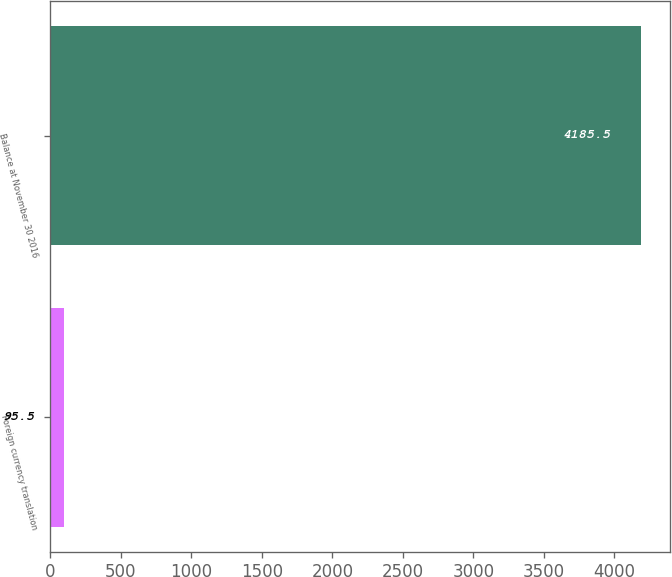<chart> <loc_0><loc_0><loc_500><loc_500><bar_chart><fcel>Foreign currency translation<fcel>Balance at November 30 2016<nl><fcel>95.5<fcel>4185.5<nl></chart> 